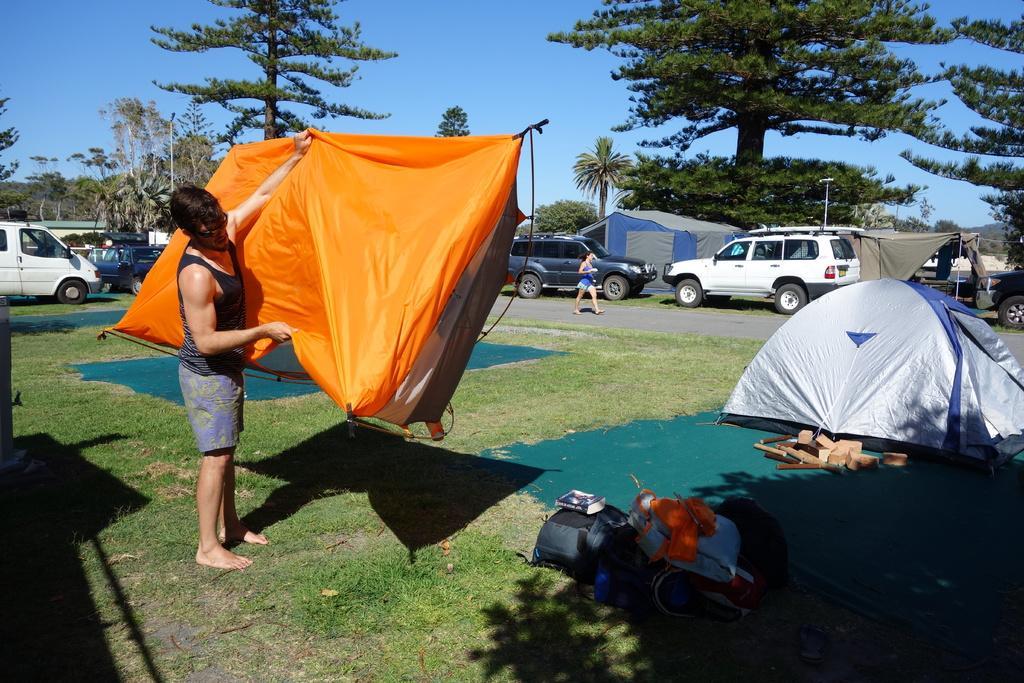Could you give a brief overview of what you see in this image? In this image I can see carpets, tents, bags, vehicles, people, trees, grass, pole and sky. Far a person is walking on the road. In the front of the image a person is holding a tent.   